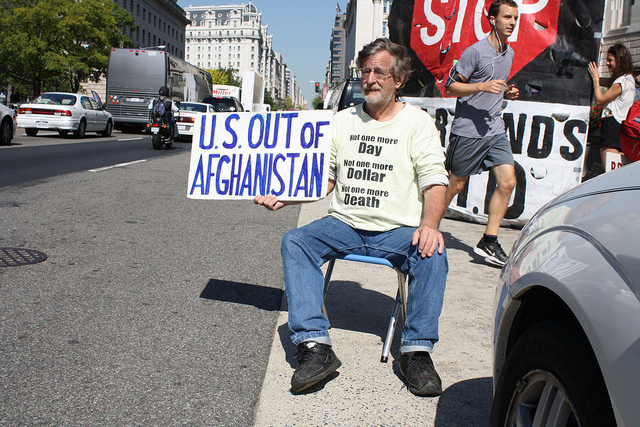Identify the text displayed in this image. AFGHANISTAN OF OUT Day Dollar D NDS R STOP oeath more one Not Not one more more one Not S U 